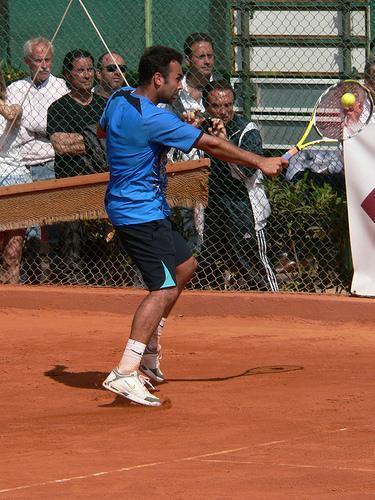How many people wear a blue t-shirt blue with black in the picture?
Give a very brief answer. 1. 